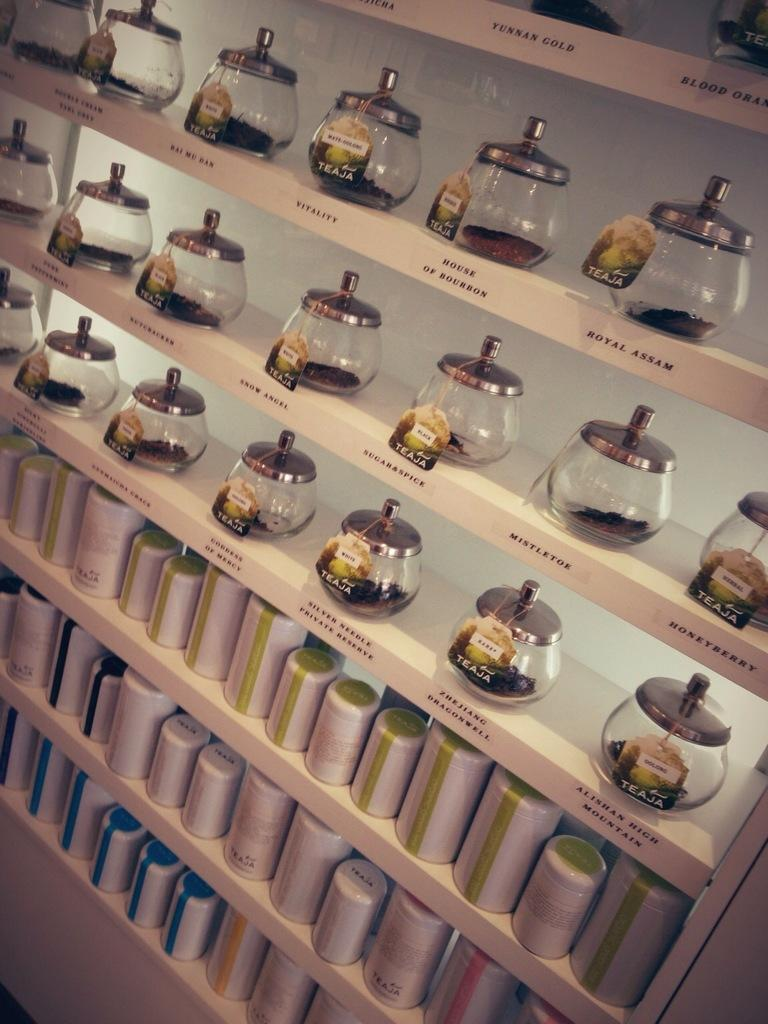What is the main subject of the image? The main subject of the image is a group of containers. How are the containers arranged in the image? The containers are placed on racks in the image. Are there any distinguishing features on the containers? Some containers have tags, and some have text on them. Can you tell me how many donkeys are standing next to the containers in the image? There are no donkeys present in the image; it only features a group of containers on racks. What type of light source is illuminating the containers in the image? There is no specific light source mentioned or visible in the image; it only shows the containers on racks. 